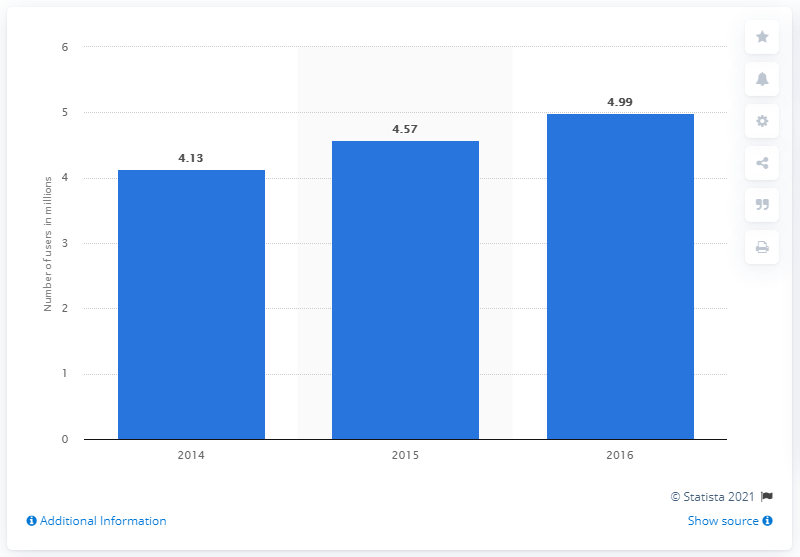Indicate a few pertinent items in this graphic. In 2015, there were approximately 4.57 million Twitter users in Saudi Arabia. 